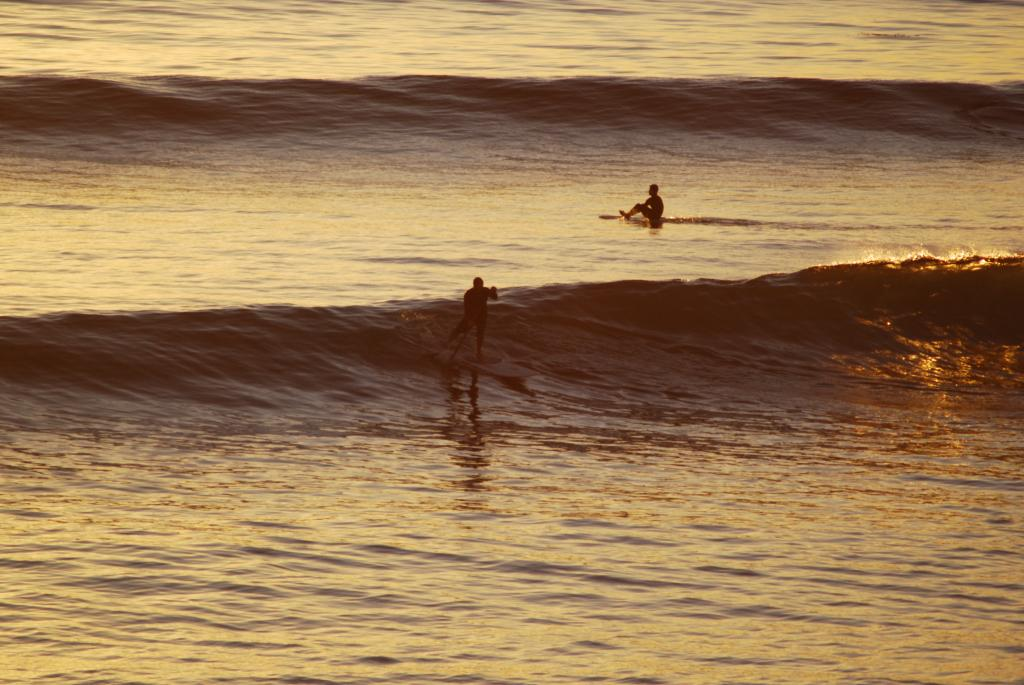How many people are in the water in the image? There are two persons in the water in the image. What can be observed in the water besides the people? Waves are visible in the image. What type of writing can be seen on the slope in the image? There is no slope or writing present in the image; it features two persons in the water with visible waves. 